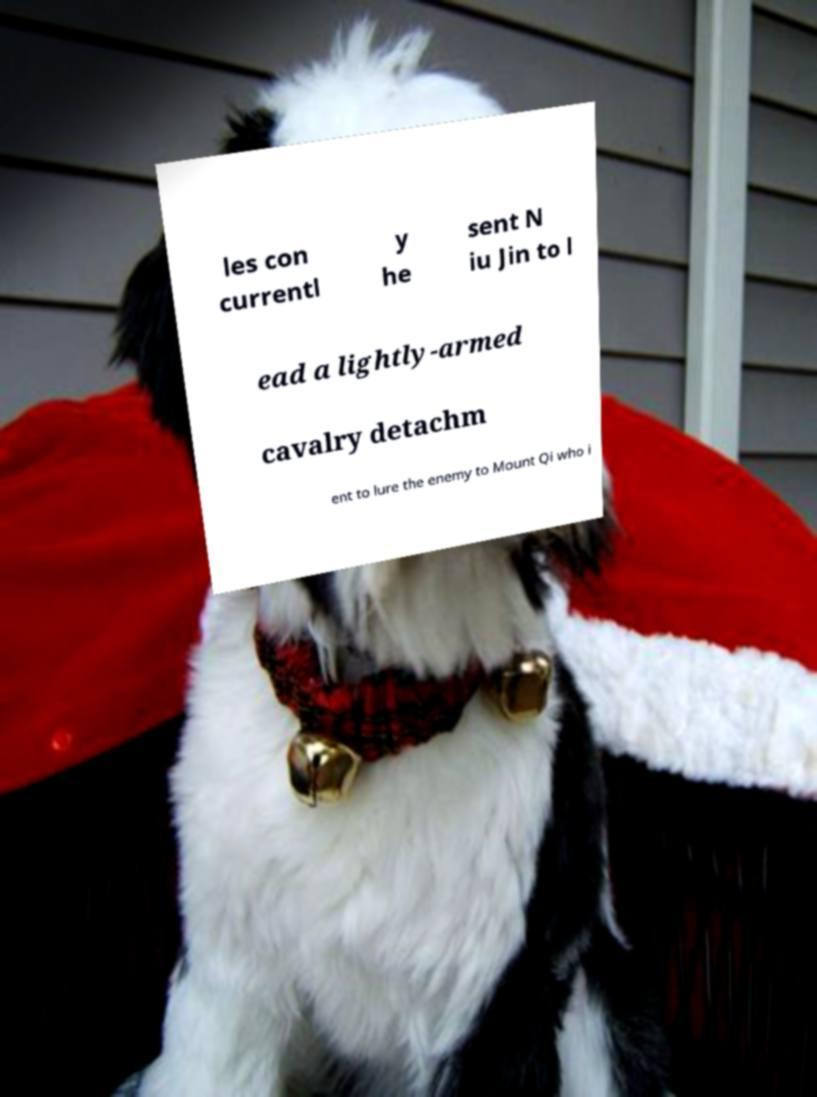Please read and relay the text visible in this image. What does it say? les con currentl y he sent N iu Jin to l ead a lightly-armed cavalry detachm ent to lure the enemy to Mount Qi who i 